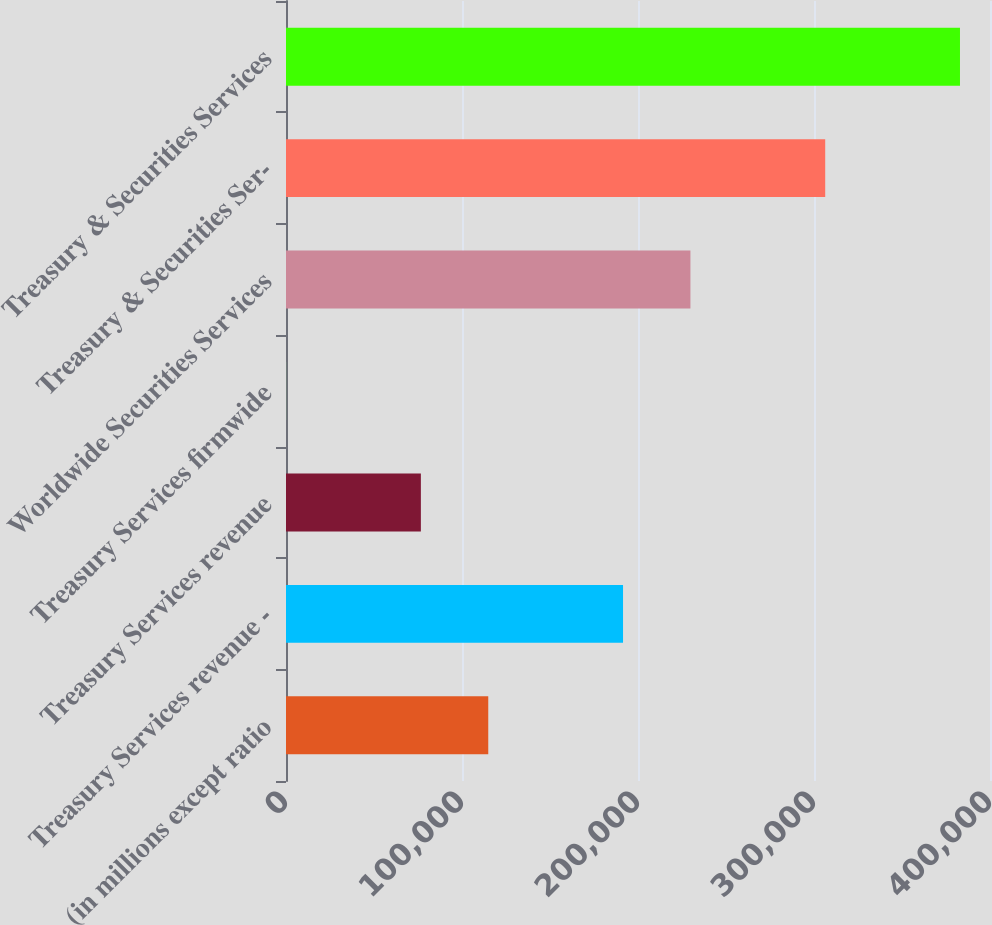Convert chart. <chart><loc_0><loc_0><loc_500><loc_500><bar_chart><fcel>(in millions except ratio<fcel>Treasury Services revenue -<fcel>Treasury Services revenue<fcel>Treasury Services firmwide<fcel>Worldwide Securities Services<fcel>Treasury & Securities Ser-<fcel>Treasury & Securities Services<nl><fcel>114919<fcel>191498<fcel>76629.4<fcel>50<fcel>229788<fcel>306368<fcel>382947<nl></chart> 